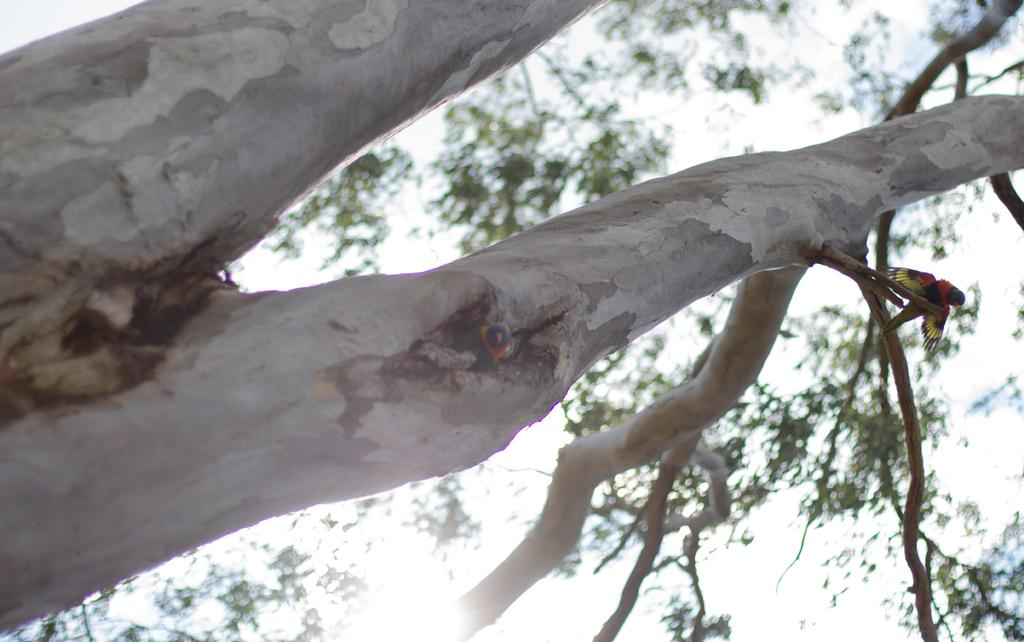What is the main subject of the picture? The main subject of the picture is a tree. Can you describe the tree in the picture? The tree has a trunk. Are there any animals visible in the picture? Yes, there is a bird on a branch of the tree on the right side. What type of pump can be seen attached to the tree in the image? There is no pump present in the image; it features a tree with a bird on a branch. Can you tell me how many sons are visible in the image? There are no sons present in the image; it features a tree with a bird on a branch. 